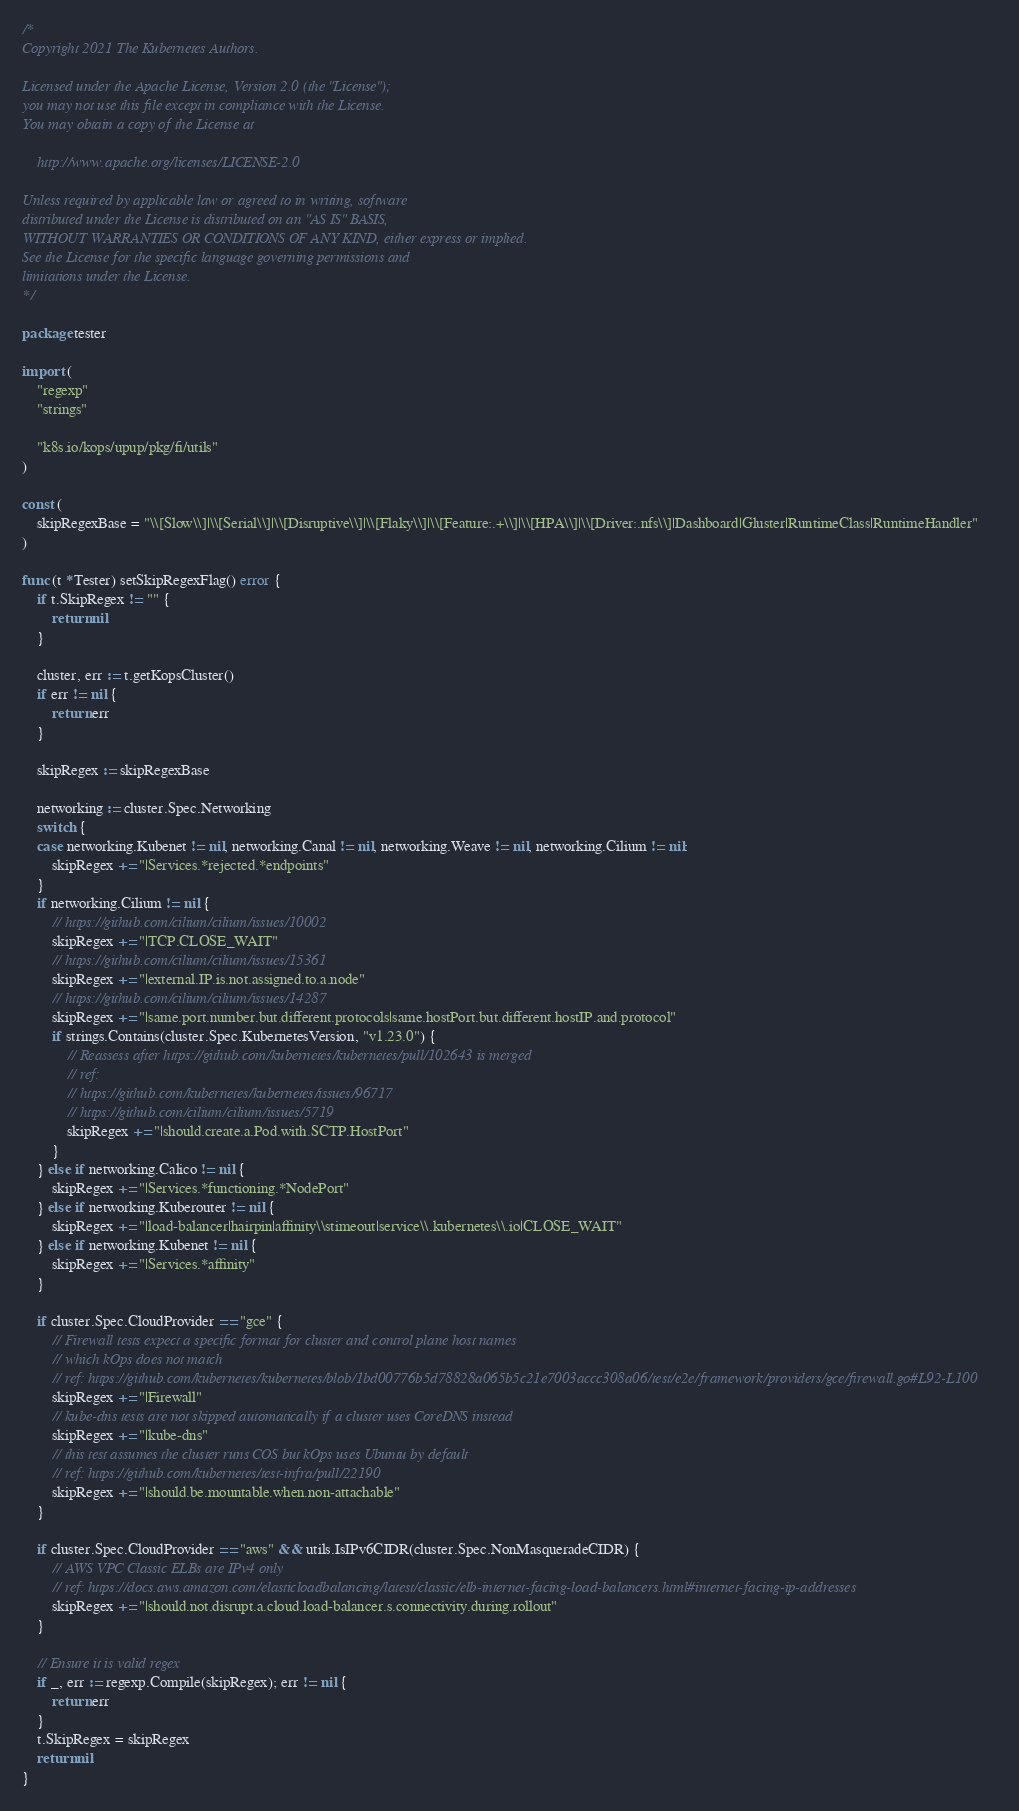Convert code to text. <code><loc_0><loc_0><loc_500><loc_500><_Go_>/*
Copyright 2021 The Kubernetes Authors.

Licensed under the Apache License, Version 2.0 (the "License");
you may not use this file except in compliance with the License.
You may obtain a copy of the License at

    http://www.apache.org/licenses/LICENSE-2.0

Unless required by applicable law or agreed to in writing, software
distributed under the License is distributed on an "AS IS" BASIS,
WITHOUT WARRANTIES OR CONDITIONS OF ANY KIND, either express or implied.
See the License for the specific language governing permissions and
limitations under the License.
*/

package tester

import (
	"regexp"
	"strings"

	"k8s.io/kops/upup/pkg/fi/utils"
)

const (
	skipRegexBase = "\\[Slow\\]|\\[Serial\\]|\\[Disruptive\\]|\\[Flaky\\]|\\[Feature:.+\\]|\\[HPA\\]|\\[Driver:.nfs\\]|Dashboard|Gluster|RuntimeClass|RuntimeHandler"
)

func (t *Tester) setSkipRegexFlag() error {
	if t.SkipRegex != "" {
		return nil
	}

	cluster, err := t.getKopsCluster()
	if err != nil {
		return err
	}

	skipRegex := skipRegexBase

	networking := cluster.Spec.Networking
	switch {
	case networking.Kubenet != nil, networking.Canal != nil, networking.Weave != nil, networking.Cilium != nil:
		skipRegex += "|Services.*rejected.*endpoints"
	}
	if networking.Cilium != nil {
		// https://github.com/cilium/cilium/issues/10002
		skipRegex += "|TCP.CLOSE_WAIT"
		// https://github.com/cilium/cilium/issues/15361
		skipRegex += "|external.IP.is.not.assigned.to.a.node"
		// https://github.com/cilium/cilium/issues/14287
		skipRegex += "|same.port.number.but.different.protocols|same.hostPort.but.different.hostIP.and.protocol"
		if strings.Contains(cluster.Spec.KubernetesVersion, "v1.23.0") {
			// Reassess after https://github.com/kubernetes/kubernetes/pull/102643 is merged
			// ref:
			// https://github.com/kubernetes/kubernetes/issues/96717
			// https://github.com/cilium/cilium/issues/5719
			skipRegex += "|should.create.a.Pod.with.SCTP.HostPort"
		}
	} else if networking.Calico != nil {
		skipRegex += "|Services.*functioning.*NodePort"
	} else if networking.Kuberouter != nil {
		skipRegex += "|load-balancer|hairpin|affinity\\stimeout|service\\.kubernetes\\.io|CLOSE_WAIT"
	} else if networking.Kubenet != nil {
		skipRegex += "|Services.*affinity"
	}

	if cluster.Spec.CloudProvider == "gce" {
		// Firewall tests expect a specific format for cluster and control plane host names
		// which kOps does not match
		// ref: https://github.com/kubernetes/kubernetes/blob/1bd00776b5d78828a065b5c21e7003accc308a06/test/e2e/framework/providers/gce/firewall.go#L92-L100
		skipRegex += "|Firewall"
		// kube-dns tests are not skipped automatically if a cluster uses CoreDNS instead
		skipRegex += "|kube-dns"
		// this test assumes the cluster runs COS but kOps uses Ubuntu by default
		// ref: https://github.com/kubernetes/test-infra/pull/22190
		skipRegex += "|should.be.mountable.when.non-attachable"
	}

	if cluster.Spec.CloudProvider == "aws" && utils.IsIPv6CIDR(cluster.Spec.NonMasqueradeCIDR) {
		// AWS VPC Classic ELBs are IPv4 only
		// ref: https://docs.aws.amazon.com/elasticloadbalancing/latest/classic/elb-internet-facing-load-balancers.html#internet-facing-ip-addresses
		skipRegex += "|should.not.disrupt.a.cloud.load-balancer.s.connectivity.during.rollout"
	}

	// Ensure it is valid regex
	if _, err := regexp.Compile(skipRegex); err != nil {
		return err
	}
	t.SkipRegex = skipRegex
	return nil
}
</code> 